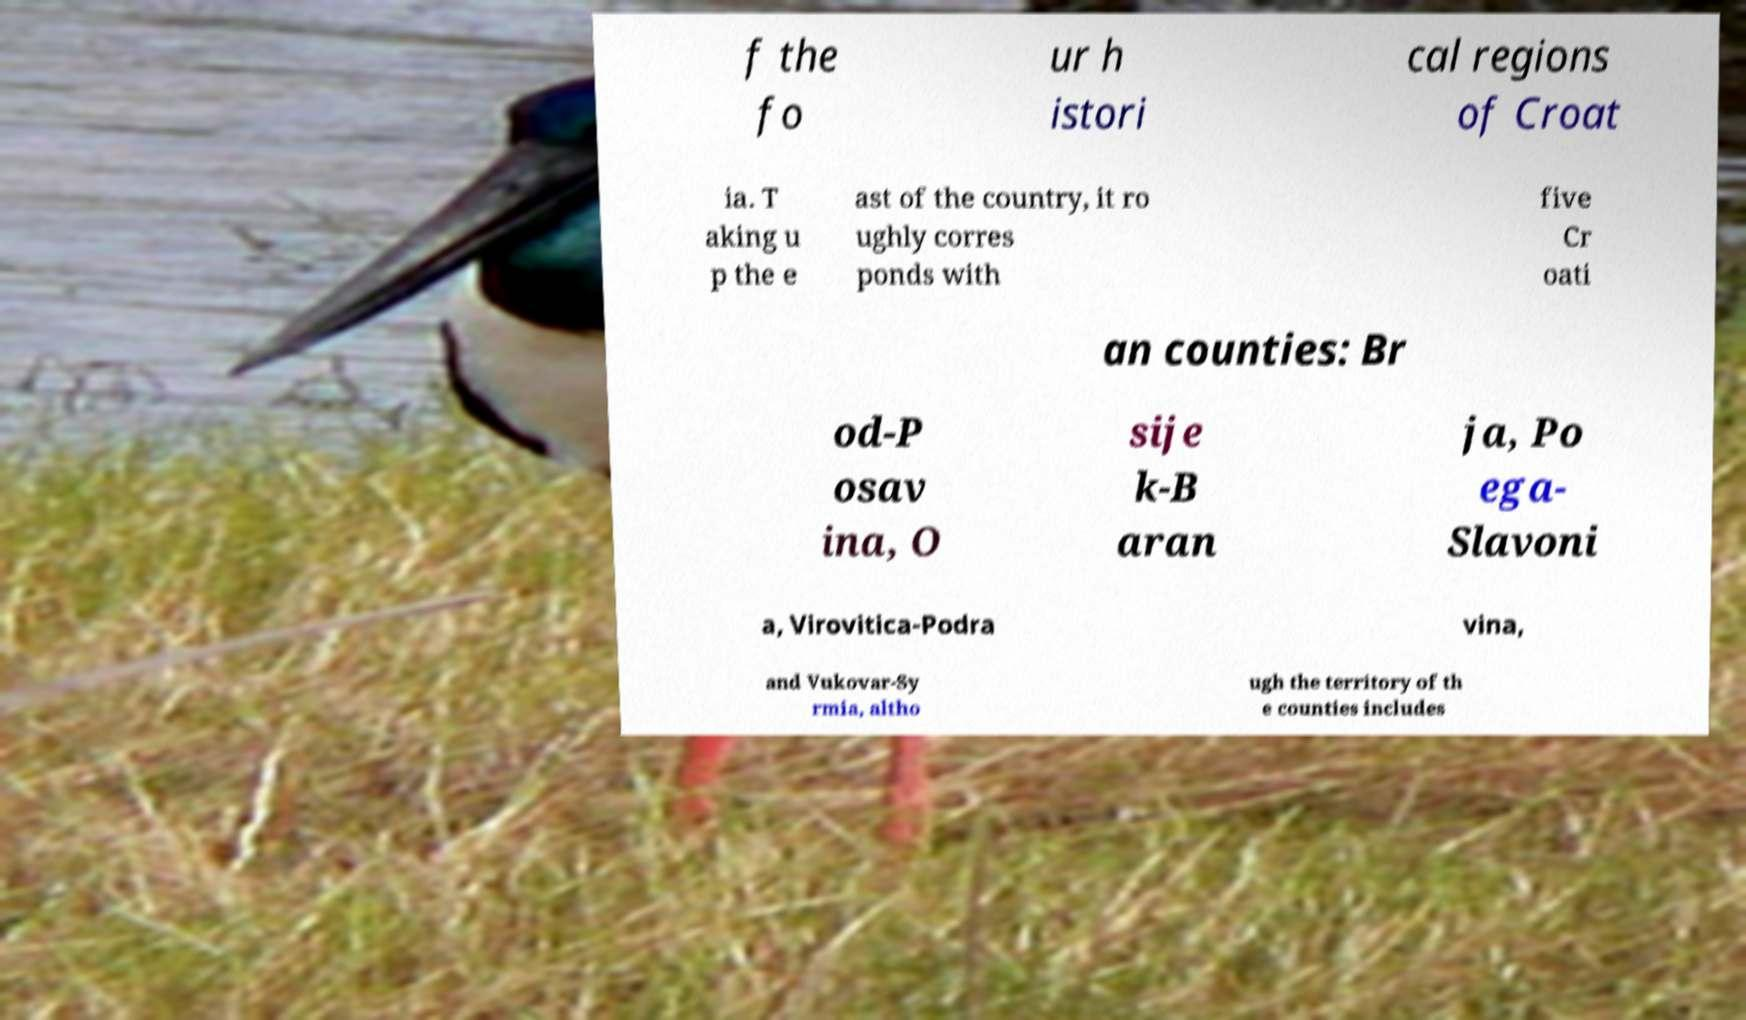Could you extract and type out the text from this image? f the fo ur h istori cal regions of Croat ia. T aking u p the e ast of the country, it ro ughly corres ponds with five Cr oati an counties: Br od-P osav ina, O sije k-B aran ja, Po ega- Slavoni a, Virovitica-Podra vina, and Vukovar-Sy rmia, altho ugh the territory of th e counties includes 